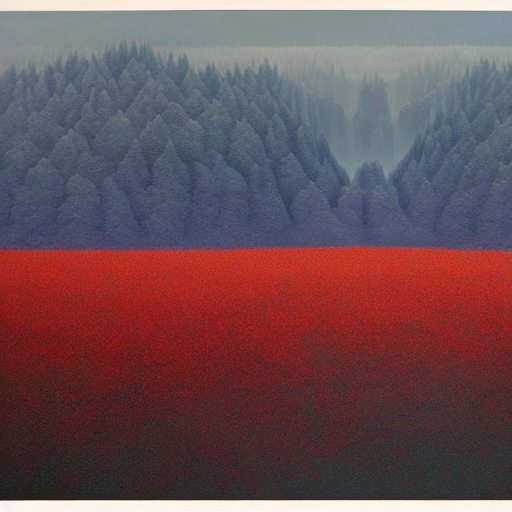What time of day does this image seem to capture? The image appears to capture a time around dawn or dusk when the light is soft and the colors are rich and muted. The absence of harsh shadows indicates that the sun is low on the horizon. Could this image be portraying the effects of a particular season? Yes, the presence of the mist or haze settling over the trees suggests cooler temperatures, indicative of either late autumn or early spring, times when temperature differences between night and day can cause such atmospheric conditions. 